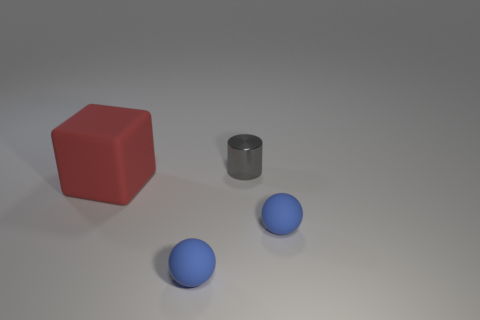What number of big things are cylinders or red rubber cubes?
Provide a succinct answer. 1. Are there fewer tiny cylinders that are left of the big cube than blocks that are in front of the metallic thing?
Your response must be concise. Yes. How many objects are either balls or big red things?
Provide a short and direct response. 3. What number of matte blocks are behind the large red matte cube?
Make the answer very short. 0. Is the color of the rubber block the same as the shiny cylinder?
Offer a very short reply. No. There is a tiny matte thing that is on the left side of the tiny gray metallic cylinder; is it the same shape as the small gray object?
Offer a terse response. No. What number of gray objects are large blocks or small shiny cylinders?
Your answer should be very brief. 1. Are there an equal number of tiny gray objects on the left side of the red block and small gray objects in front of the small gray object?
Give a very brief answer. Yes. What color is the tiny thing that is behind the tiny blue rubber sphere to the right of the thing that is behind the big thing?
Give a very brief answer. Gray. Is there anything else that has the same color as the large cube?
Give a very brief answer. No. 